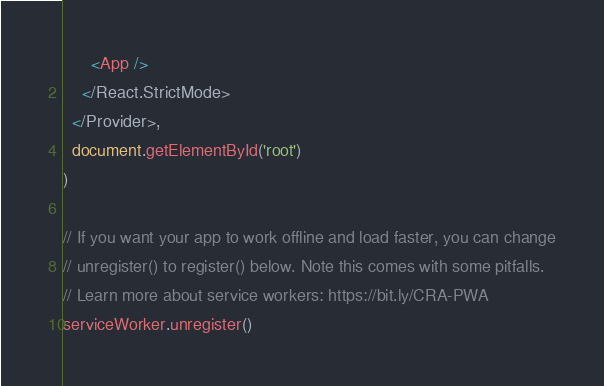<code> <loc_0><loc_0><loc_500><loc_500><_TypeScript_>      <App />
    </React.StrictMode>
  </Provider>,
  document.getElementById('root')
)

// If you want your app to work offline and load faster, you can change
// unregister() to register() below. Note this comes with some pitfalls.
// Learn more about service workers: https://bit.ly/CRA-PWA
serviceWorker.unregister()
</code> 